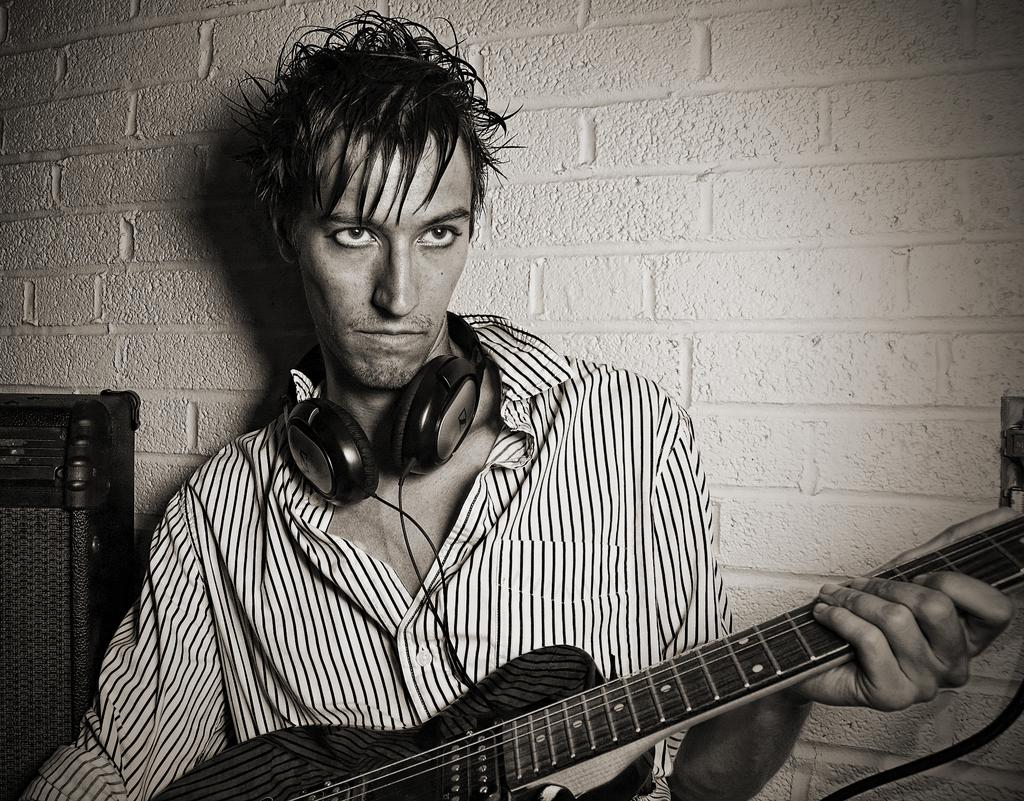Who is present in the image? There is a man in the image. What is the man holding in the image? The man is holding a guitar. What accessory is the man wearing around his neck? The man is wearing a headset around his neck. What can be seen in the background of the image? There is a wall in the background of the image. What type of bean is being served for dinner in the image? There is no bean or dinner present in the image; it features a man holding a guitar and wearing a headset. 